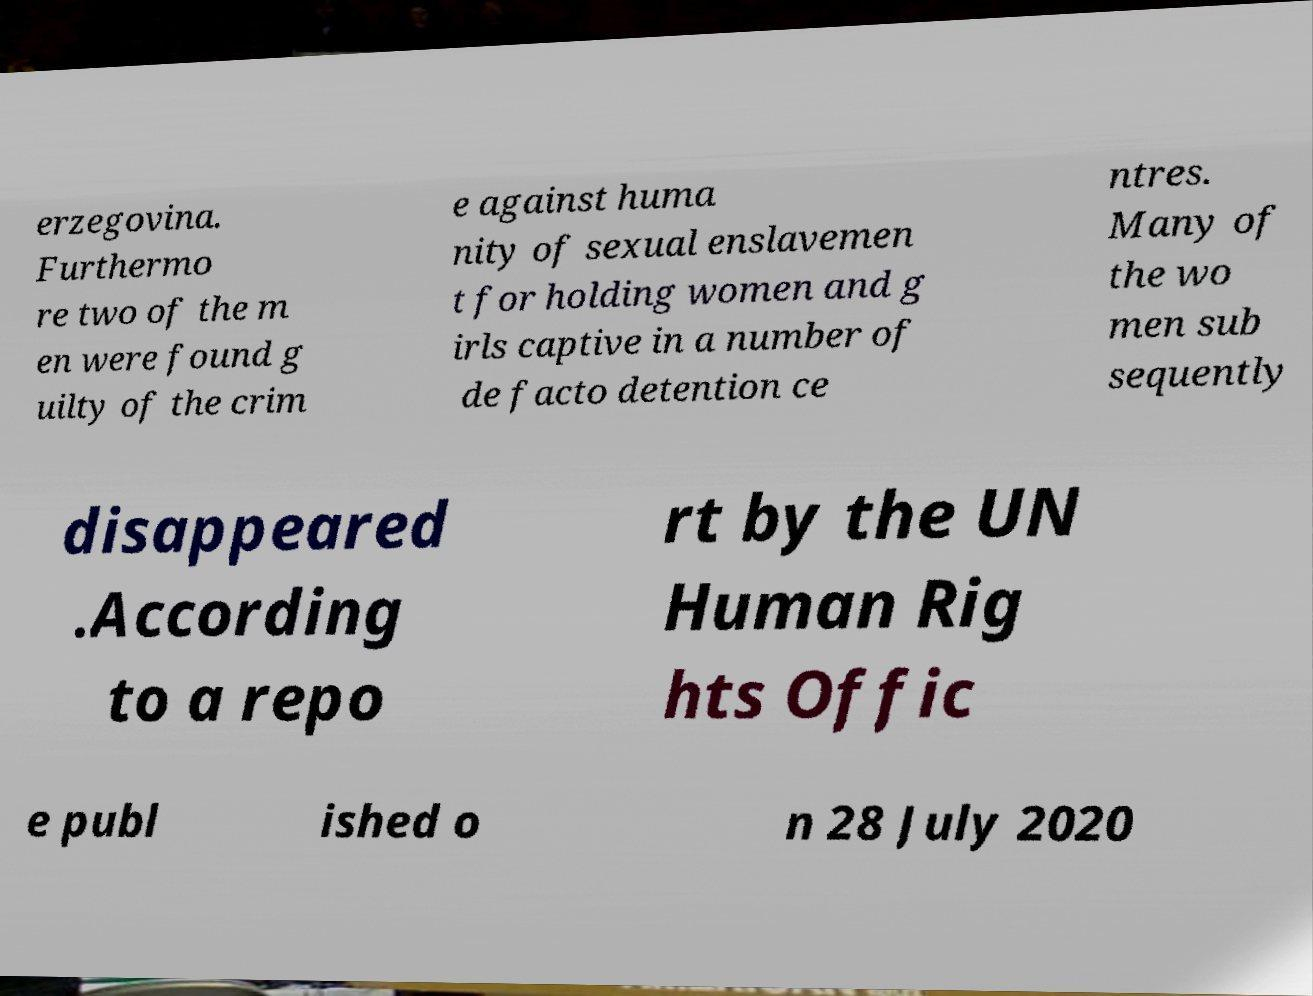Please read and relay the text visible in this image. What does it say? erzegovina. Furthermo re two of the m en were found g uilty of the crim e against huma nity of sexual enslavemen t for holding women and g irls captive in a number of de facto detention ce ntres. Many of the wo men sub sequently disappeared .According to a repo rt by the UN Human Rig hts Offic e publ ished o n 28 July 2020 